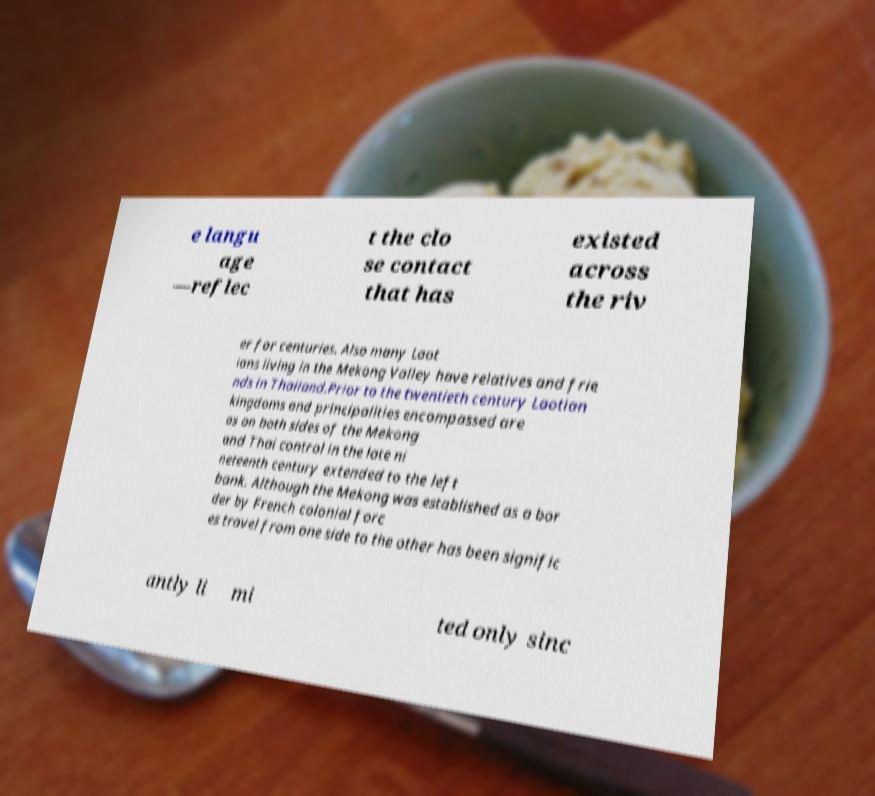Could you extract and type out the text from this image? e langu age —reflec t the clo se contact that has existed across the riv er for centuries. Also many Laot ians living in the Mekong Valley have relatives and frie nds in Thailand.Prior to the twentieth century Laotian kingdoms and principalities encompassed are as on both sides of the Mekong and Thai control in the late ni neteenth century extended to the left bank. Although the Mekong was established as a bor der by French colonial forc es travel from one side to the other has been signific antly li mi ted only sinc 